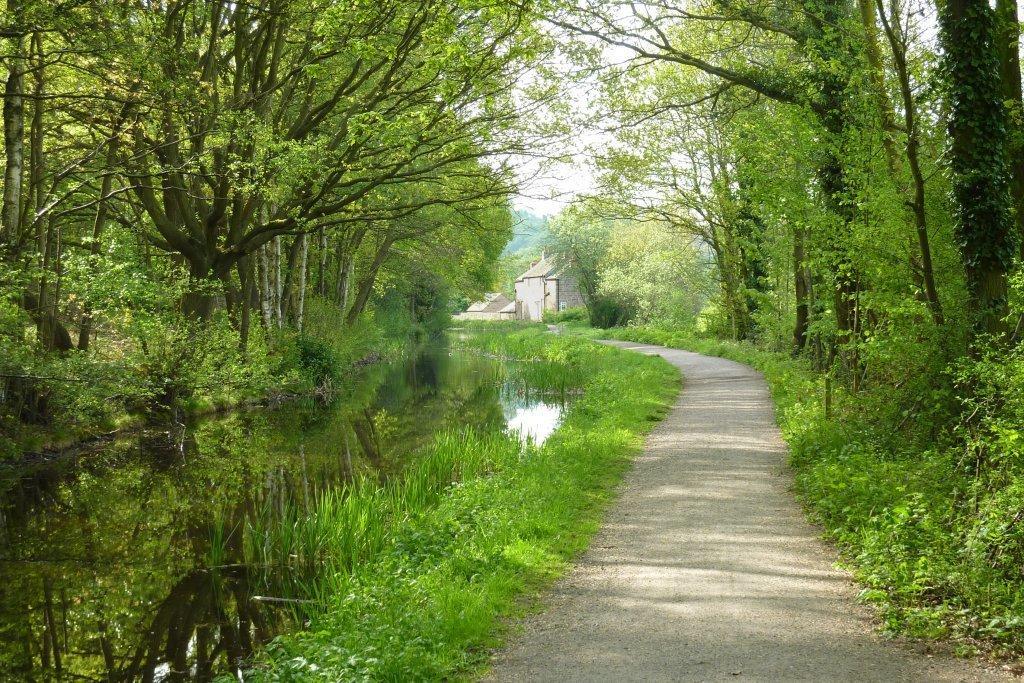Could you give a brief overview of what you see in this image? In the foreground of this image, there is a path. On the right, there are trees. On the left, there are trees, water and the grass. In the background, there are few houses and the sky. 